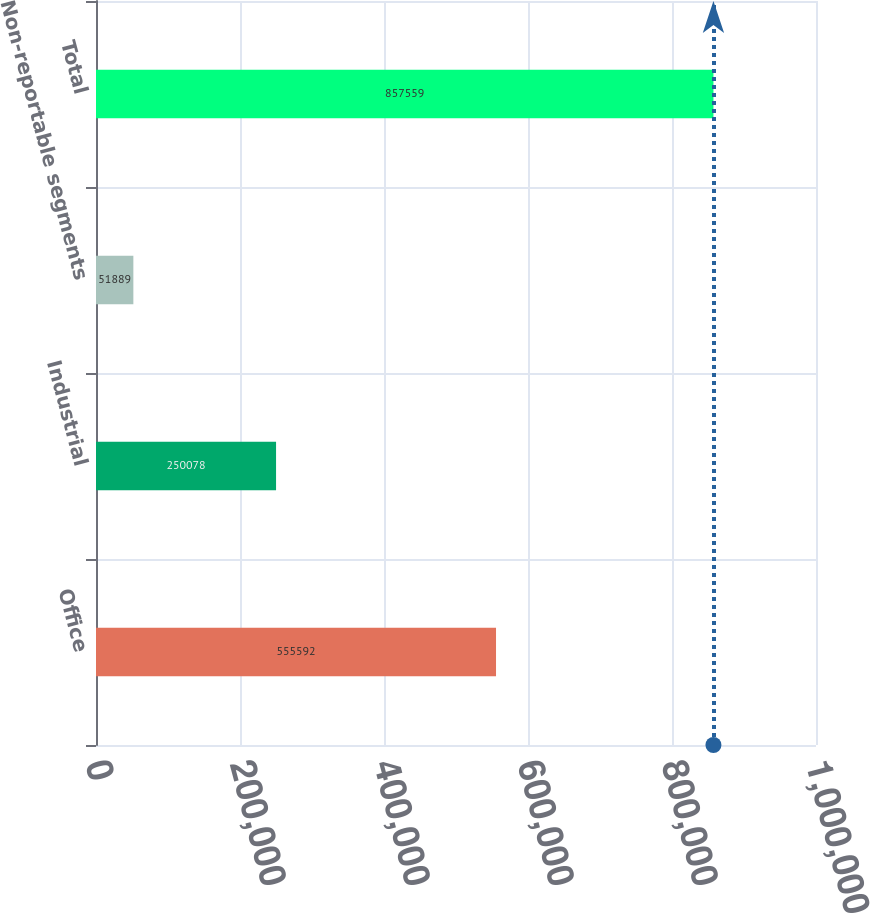Convert chart. <chart><loc_0><loc_0><loc_500><loc_500><bar_chart><fcel>Office<fcel>Industrial<fcel>Non-reportable segments<fcel>Total<nl><fcel>555592<fcel>250078<fcel>51889<fcel>857559<nl></chart> 